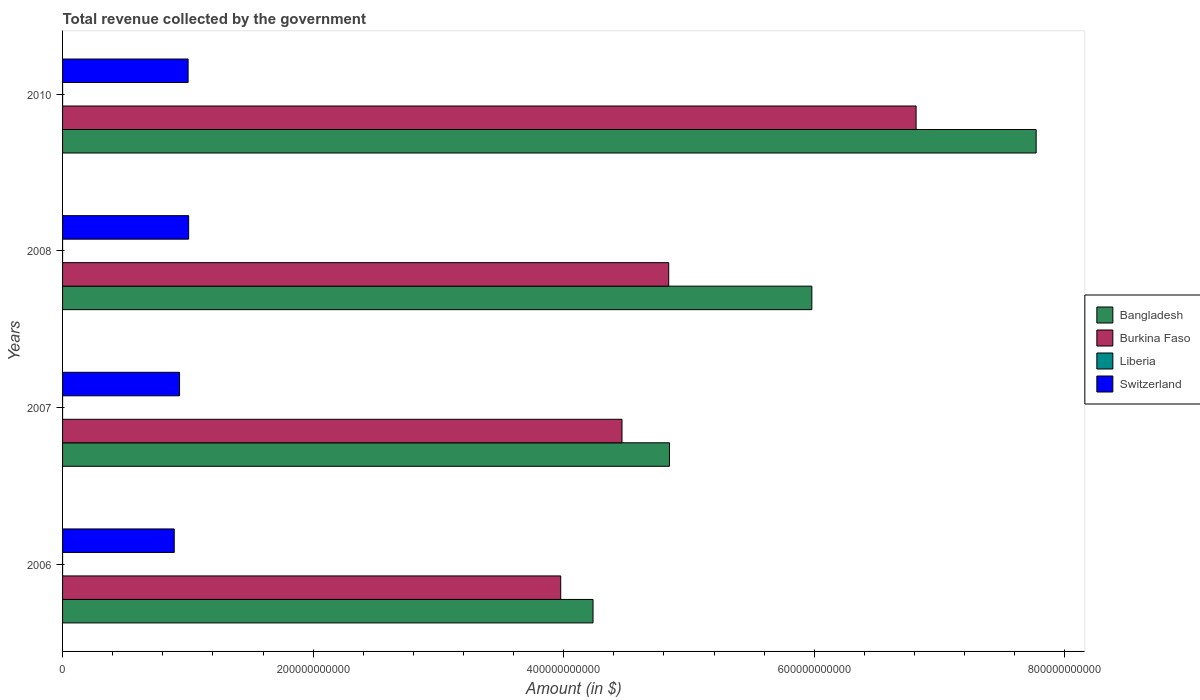How many different coloured bars are there?
Ensure brevity in your answer.  4. How many groups of bars are there?
Your response must be concise. 4. Are the number of bars per tick equal to the number of legend labels?
Make the answer very short. Yes. How many bars are there on the 1st tick from the top?
Provide a succinct answer. 4. How many bars are there on the 2nd tick from the bottom?
Give a very brief answer. 4. What is the label of the 2nd group of bars from the top?
Provide a succinct answer. 2008. In how many cases, is the number of bars for a given year not equal to the number of legend labels?
Keep it short and to the point. 0. What is the total revenue collected by the government in Burkina Faso in 2010?
Your response must be concise. 6.81e+11. Across all years, what is the maximum total revenue collected by the government in Burkina Faso?
Offer a very short reply. 6.81e+11. Across all years, what is the minimum total revenue collected by the government in Burkina Faso?
Offer a very short reply. 3.98e+11. In which year was the total revenue collected by the government in Switzerland maximum?
Your answer should be compact. 2008. In which year was the total revenue collected by the government in Bangladesh minimum?
Make the answer very short. 2006. What is the total total revenue collected by the government in Liberia in the graph?
Ensure brevity in your answer.  1.08e+07. What is the difference between the total revenue collected by the government in Bangladesh in 2006 and that in 2010?
Your answer should be compact. -3.54e+11. What is the difference between the total revenue collected by the government in Liberia in 2006 and the total revenue collected by the government in Bangladesh in 2007?
Make the answer very short. -4.84e+11. What is the average total revenue collected by the government in Bangladesh per year?
Offer a terse response. 5.71e+11. In the year 2008, what is the difference between the total revenue collected by the government in Burkina Faso and total revenue collected by the government in Bangladesh?
Make the answer very short. -1.14e+11. In how many years, is the total revenue collected by the government in Burkina Faso greater than 600000000000 $?
Offer a terse response. 1. What is the ratio of the total revenue collected by the government in Bangladesh in 2006 to that in 2008?
Make the answer very short. 0.71. Is the total revenue collected by the government in Switzerland in 2007 less than that in 2010?
Ensure brevity in your answer.  Yes. Is the difference between the total revenue collected by the government in Burkina Faso in 2007 and 2008 greater than the difference between the total revenue collected by the government in Bangladesh in 2007 and 2008?
Your response must be concise. Yes. What is the difference between the highest and the second highest total revenue collected by the government in Bangladesh?
Provide a short and direct response. 1.79e+11. What is the difference between the highest and the lowest total revenue collected by the government in Bangladesh?
Offer a very short reply. 3.54e+11. Is the sum of the total revenue collected by the government in Burkina Faso in 2008 and 2010 greater than the maximum total revenue collected by the government in Switzerland across all years?
Offer a very short reply. Yes. Is it the case that in every year, the sum of the total revenue collected by the government in Burkina Faso and total revenue collected by the government in Bangladesh is greater than the sum of total revenue collected by the government in Switzerland and total revenue collected by the government in Liberia?
Provide a succinct answer. No. What does the 1st bar from the top in 2007 represents?
Make the answer very short. Switzerland. What does the 2nd bar from the bottom in 2010 represents?
Provide a succinct answer. Burkina Faso. Are all the bars in the graph horizontal?
Offer a very short reply. Yes. How many years are there in the graph?
Keep it short and to the point. 4. What is the difference between two consecutive major ticks on the X-axis?
Your answer should be very brief. 2.00e+11. Does the graph contain grids?
Make the answer very short. No. Where does the legend appear in the graph?
Offer a very short reply. Center right. What is the title of the graph?
Your response must be concise. Total revenue collected by the government. What is the label or title of the X-axis?
Provide a short and direct response. Amount (in $). What is the label or title of the Y-axis?
Your answer should be very brief. Years. What is the Amount (in $) of Bangladesh in 2006?
Keep it short and to the point. 4.23e+11. What is the Amount (in $) of Burkina Faso in 2006?
Offer a very short reply. 3.98e+11. What is the Amount (in $) of Liberia in 2006?
Give a very brief answer. 1.46e+06. What is the Amount (in $) in Switzerland in 2006?
Provide a succinct answer. 8.91e+1. What is the Amount (in $) in Bangladesh in 2007?
Ensure brevity in your answer.  4.84e+11. What is the Amount (in $) of Burkina Faso in 2007?
Offer a very short reply. 4.47e+11. What is the Amount (in $) in Liberia in 2007?
Offer a very short reply. 2.40e+06. What is the Amount (in $) of Switzerland in 2007?
Offer a terse response. 9.34e+1. What is the Amount (in $) of Bangladesh in 2008?
Ensure brevity in your answer.  5.98e+11. What is the Amount (in $) of Burkina Faso in 2008?
Offer a very short reply. 4.84e+11. What is the Amount (in $) in Liberia in 2008?
Give a very brief answer. 3.18e+06. What is the Amount (in $) in Switzerland in 2008?
Give a very brief answer. 1.01e+11. What is the Amount (in $) in Bangladesh in 2010?
Your response must be concise. 7.77e+11. What is the Amount (in $) of Burkina Faso in 2010?
Provide a short and direct response. 6.81e+11. What is the Amount (in $) of Liberia in 2010?
Your answer should be compact. 3.78e+06. What is the Amount (in $) of Switzerland in 2010?
Make the answer very short. 1.00e+11. Across all years, what is the maximum Amount (in $) of Bangladesh?
Your answer should be very brief. 7.77e+11. Across all years, what is the maximum Amount (in $) in Burkina Faso?
Your answer should be compact. 6.81e+11. Across all years, what is the maximum Amount (in $) of Liberia?
Offer a very short reply. 3.78e+06. Across all years, what is the maximum Amount (in $) of Switzerland?
Your answer should be compact. 1.01e+11. Across all years, what is the minimum Amount (in $) of Bangladesh?
Provide a succinct answer. 4.23e+11. Across all years, what is the minimum Amount (in $) in Burkina Faso?
Give a very brief answer. 3.98e+11. Across all years, what is the minimum Amount (in $) of Liberia?
Offer a very short reply. 1.46e+06. Across all years, what is the minimum Amount (in $) of Switzerland?
Provide a short and direct response. 8.91e+1. What is the total Amount (in $) in Bangladesh in the graph?
Offer a very short reply. 2.28e+12. What is the total Amount (in $) of Burkina Faso in the graph?
Offer a terse response. 2.01e+12. What is the total Amount (in $) of Liberia in the graph?
Provide a short and direct response. 1.08e+07. What is the total Amount (in $) in Switzerland in the graph?
Ensure brevity in your answer.  3.83e+11. What is the difference between the Amount (in $) in Bangladesh in 2006 and that in 2007?
Your response must be concise. -6.10e+1. What is the difference between the Amount (in $) of Burkina Faso in 2006 and that in 2007?
Make the answer very short. -4.89e+1. What is the difference between the Amount (in $) in Liberia in 2006 and that in 2007?
Your answer should be very brief. -9.40e+05. What is the difference between the Amount (in $) in Switzerland in 2006 and that in 2007?
Ensure brevity in your answer.  -4.24e+09. What is the difference between the Amount (in $) of Bangladesh in 2006 and that in 2008?
Keep it short and to the point. -1.75e+11. What is the difference between the Amount (in $) of Burkina Faso in 2006 and that in 2008?
Your answer should be compact. -8.62e+1. What is the difference between the Amount (in $) in Liberia in 2006 and that in 2008?
Make the answer very short. -1.73e+06. What is the difference between the Amount (in $) in Switzerland in 2006 and that in 2008?
Your response must be concise. -1.15e+1. What is the difference between the Amount (in $) in Bangladesh in 2006 and that in 2010?
Your response must be concise. -3.54e+11. What is the difference between the Amount (in $) of Burkina Faso in 2006 and that in 2010?
Make the answer very short. -2.84e+11. What is the difference between the Amount (in $) in Liberia in 2006 and that in 2010?
Offer a very short reply. -2.33e+06. What is the difference between the Amount (in $) in Switzerland in 2006 and that in 2010?
Provide a short and direct response. -1.11e+1. What is the difference between the Amount (in $) of Bangladesh in 2007 and that in 2008?
Your answer should be very brief. -1.14e+11. What is the difference between the Amount (in $) of Burkina Faso in 2007 and that in 2008?
Give a very brief answer. -3.73e+1. What is the difference between the Amount (in $) of Liberia in 2007 and that in 2008?
Offer a very short reply. -7.87e+05. What is the difference between the Amount (in $) in Switzerland in 2007 and that in 2008?
Keep it short and to the point. -7.27e+09. What is the difference between the Amount (in $) of Bangladesh in 2007 and that in 2010?
Keep it short and to the point. -2.93e+11. What is the difference between the Amount (in $) in Burkina Faso in 2007 and that in 2010?
Make the answer very short. -2.35e+11. What is the difference between the Amount (in $) of Liberia in 2007 and that in 2010?
Make the answer very short. -1.39e+06. What is the difference between the Amount (in $) of Switzerland in 2007 and that in 2010?
Provide a short and direct response. -6.83e+09. What is the difference between the Amount (in $) in Bangladesh in 2008 and that in 2010?
Offer a terse response. -1.79e+11. What is the difference between the Amount (in $) of Burkina Faso in 2008 and that in 2010?
Give a very brief answer. -1.97e+11. What is the difference between the Amount (in $) of Liberia in 2008 and that in 2010?
Your answer should be very brief. -6.00e+05. What is the difference between the Amount (in $) of Switzerland in 2008 and that in 2010?
Ensure brevity in your answer.  4.42e+08. What is the difference between the Amount (in $) of Bangladesh in 2006 and the Amount (in $) of Burkina Faso in 2007?
Give a very brief answer. -2.31e+1. What is the difference between the Amount (in $) in Bangladesh in 2006 and the Amount (in $) in Liberia in 2007?
Keep it short and to the point. 4.23e+11. What is the difference between the Amount (in $) of Bangladesh in 2006 and the Amount (in $) of Switzerland in 2007?
Provide a succinct answer. 3.30e+11. What is the difference between the Amount (in $) of Burkina Faso in 2006 and the Amount (in $) of Liberia in 2007?
Offer a very short reply. 3.98e+11. What is the difference between the Amount (in $) of Burkina Faso in 2006 and the Amount (in $) of Switzerland in 2007?
Your answer should be very brief. 3.04e+11. What is the difference between the Amount (in $) of Liberia in 2006 and the Amount (in $) of Switzerland in 2007?
Your answer should be compact. -9.34e+1. What is the difference between the Amount (in $) of Bangladesh in 2006 and the Amount (in $) of Burkina Faso in 2008?
Your response must be concise. -6.04e+1. What is the difference between the Amount (in $) of Bangladesh in 2006 and the Amount (in $) of Liberia in 2008?
Your answer should be very brief. 4.23e+11. What is the difference between the Amount (in $) of Bangladesh in 2006 and the Amount (in $) of Switzerland in 2008?
Keep it short and to the point. 3.23e+11. What is the difference between the Amount (in $) in Burkina Faso in 2006 and the Amount (in $) in Liberia in 2008?
Keep it short and to the point. 3.98e+11. What is the difference between the Amount (in $) of Burkina Faso in 2006 and the Amount (in $) of Switzerland in 2008?
Your answer should be very brief. 2.97e+11. What is the difference between the Amount (in $) in Liberia in 2006 and the Amount (in $) in Switzerland in 2008?
Make the answer very short. -1.01e+11. What is the difference between the Amount (in $) of Bangladesh in 2006 and the Amount (in $) of Burkina Faso in 2010?
Your answer should be very brief. -2.58e+11. What is the difference between the Amount (in $) in Bangladesh in 2006 and the Amount (in $) in Liberia in 2010?
Offer a terse response. 4.23e+11. What is the difference between the Amount (in $) in Bangladesh in 2006 and the Amount (in $) in Switzerland in 2010?
Your answer should be compact. 3.23e+11. What is the difference between the Amount (in $) in Burkina Faso in 2006 and the Amount (in $) in Liberia in 2010?
Your response must be concise. 3.98e+11. What is the difference between the Amount (in $) in Burkina Faso in 2006 and the Amount (in $) in Switzerland in 2010?
Provide a succinct answer. 2.97e+11. What is the difference between the Amount (in $) in Liberia in 2006 and the Amount (in $) in Switzerland in 2010?
Keep it short and to the point. -1.00e+11. What is the difference between the Amount (in $) of Bangladesh in 2007 and the Amount (in $) of Burkina Faso in 2008?
Offer a terse response. 5.88e+08. What is the difference between the Amount (in $) of Bangladesh in 2007 and the Amount (in $) of Liberia in 2008?
Your response must be concise. 4.84e+11. What is the difference between the Amount (in $) in Bangladesh in 2007 and the Amount (in $) in Switzerland in 2008?
Your answer should be very brief. 3.84e+11. What is the difference between the Amount (in $) in Burkina Faso in 2007 and the Amount (in $) in Liberia in 2008?
Ensure brevity in your answer.  4.47e+11. What is the difference between the Amount (in $) of Burkina Faso in 2007 and the Amount (in $) of Switzerland in 2008?
Offer a very short reply. 3.46e+11. What is the difference between the Amount (in $) in Liberia in 2007 and the Amount (in $) in Switzerland in 2008?
Make the answer very short. -1.01e+11. What is the difference between the Amount (in $) in Bangladesh in 2007 and the Amount (in $) in Burkina Faso in 2010?
Provide a succinct answer. -1.97e+11. What is the difference between the Amount (in $) in Bangladesh in 2007 and the Amount (in $) in Liberia in 2010?
Ensure brevity in your answer.  4.84e+11. What is the difference between the Amount (in $) in Bangladesh in 2007 and the Amount (in $) in Switzerland in 2010?
Offer a very short reply. 3.84e+11. What is the difference between the Amount (in $) of Burkina Faso in 2007 and the Amount (in $) of Liberia in 2010?
Make the answer very short. 4.47e+11. What is the difference between the Amount (in $) of Burkina Faso in 2007 and the Amount (in $) of Switzerland in 2010?
Provide a short and direct response. 3.46e+11. What is the difference between the Amount (in $) in Liberia in 2007 and the Amount (in $) in Switzerland in 2010?
Provide a succinct answer. -1.00e+11. What is the difference between the Amount (in $) of Bangladesh in 2008 and the Amount (in $) of Burkina Faso in 2010?
Make the answer very short. -8.32e+1. What is the difference between the Amount (in $) in Bangladesh in 2008 and the Amount (in $) in Liberia in 2010?
Ensure brevity in your answer.  5.98e+11. What is the difference between the Amount (in $) in Bangladesh in 2008 and the Amount (in $) in Switzerland in 2010?
Ensure brevity in your answer.  4.98e+11. What is the difference between the Amount (in $) in Burkina Faso in 2008 and the Amount (in $) in Liberia in 2010?
Your answer should be very brief. 4.84e+11. What is the difference between the Amount (in $) in Burkina Faso in 2008 and the Amount (in $) in Switzerland in 2010?
Offer a very short reply. 3.84e+11. What is the difference between the Amount (in $) of Liberia in 2008 and the Amount (in $) of Switzerland in 2010?
Keep it short and to the point. -1.00e+11. What is the average Amount (in $) in Bangladesh per year?
Offer a terse response. 5.71e+11. What is the average Amount (in $) of Burkina Faso per year?
Give a very brief answer. 5.02e+11. What is the average Amount (in $) of Liberia per year?
Provide a succinct answer. 2.70e+06. What is the average Amount (in $) in Switzerland per year?
Provide a succinct answer. 9.58e+1. In the year 2006, what is the difference between the Amount (in $) of Bangladesh and Amount (in $) of Burkina Faso?
Your answer should be very brief. 2.58e+1. In the year 2006, what is the difference between the Amount (in $) in Bangladesh and Amount (in $) in Liberia?
Keep it short and to the point. 4.23e+11. In the year 2006, what is the difference between the Amount (in $) of Bangladesh and Amount (in $) of Switzerland?
Your answer should be very brief. 3.34e+11. In the year 2006, what is the difference between the Amount (in $) of Burkina Faso and Amount (in $) of Liberia?
Offer a very short reply. 3.98e+11. In the year 2006, what is the difference between the Amount (in $) of Burkina Faso and Amount (in $) of Switzerland?
Your answer should be compact. 3.08e+11. In the year 2006, what is the difference between the Amount (in $) in Liberia and Amount (in $) in Switzerland?
Make the answer very short. -8.91e+1. In the year 2007, what is the difference between the Amount (in $) of Bangladesh and Amount (in $) of Burkina Faso?
Offer a very short reply. 3.79e+1. In the year 2007, what is the difference between the Amount (in $) of Bangladesh and Amount (in $) of Liberia?
Offer a terse response. 4.84e+11. In the year 2007, what is the difference between the Amount (in $) in Bangladesh and Amount (in $) in Switzerland?
Offer a terse response. 3.91e+11. In the year 2007, what is the difference between the Amount (in $) of Burkina Faso and Amount (in $) of Liberia?
Your answer should be very brief. 4.47e+11. In the year 2007, what is the difference between the Amount (in $) in Burkina Faso and Amount (in $) in Switzerland?
Provide a succinct answer. 3.53e+11. In the year 2007, what is the difference between the Amount (in $) in Liberia and Amount (in $) in Switzerland?
Offer a terse response. -9.34e+1. In the year 2008, what is the difference between the Amount (in $) in Bangladesh and Amount (in $) in Burkina Faso?
Provide a short and direct response. 1.14e+11. In the year 2008, what is the difference between the Amount (in $) of Bangladesh and Amount (in $) of Liberia?
Provide a succinct answer. 5.98e+11. In the year 2008, what is the difference between the Amount (in $) of Bangladesh and Amount (in $) of Switzerland?
Offer a terse response. 4.97e+11. In the year 2008, what is the difference between the Amount (in $) in Burkina Faso and Amount (in $) in Liberia?
Offer a terse response. 4.84e+11. In the year 2008, what is the difference between the Amount (in $) in Burkina Faso and Amount (in $) in Switzerland?
Your response must be concise. 3.83e+11. In the year 2008, what is the difference between the Amount (in $) of Liberia and Amount (in $) of Switzerland?
Your response must be concise. -1.01e+11. In the year 2010, what is the difference between the Amount (in $) in Bangladesh and Amount (in $) in Burkina Faso?
Offer a very short reply. 9.58e+1. In the year 2010, what is the difference between the Amount (in $) in Bangladesh and Amount (in $) in Liberia?
Your response must be concise. 7.77e+11. In the year 2010, what is the difference between the Amount (in $) of Bangladesh and Amount (in $) of Switzerland?
Give a very brief answer. 6.77e+11. In the year 2010, what is the difference between the Amount (in $) in Burkina Faso and Amount (in $) in Liberia?
Make the answer very short. 6.81e+11. In the year 2010, what is the difference between the Amount (in $) of Burkina Faso and Amount (in $) of Switzerland?
Ensure brevity in your answer.  5.81e+11. In the year 2010, what is the difference between the Amount (in $) in Liberia and Amount (in $) in Switzerland?
Make the answer very short. -1.00e+11. What is the ratio of the Amount (in $) of Bangladesh in 2006 to that in 2007?
Provide a succinct answer. 0.87. What is the ratio of the Amount (in $) of Burkina Faso in 2006 to that in 2007?
Your answer should be compact. 0.89. What is the ratio of the Amount (in $) of Liberia in 2006 to that in 2007?
Offer a very short reply. 0.61. What is the ratio of the Amount (in $) in Switzerland in 2006 to that in 2007?
Make the answer very short. 0.95. What is the ratio of the Amount (in $) in Bangladesh in 2006 to that in 2008?
Provide a succinct answer. 0.71. What is the ratio of the Amount (in $) of Burkina Faso in 2006 to that in 2008?
Make the answer very short. 0.82. What is the ratio of the Amount (in $) in Liberia in 2006 to that in 2008?
Your answer should be very brief. 0.46. What is the ratio of the Amount (in $) of Switzerland in 2006 to that in 2008?
Ensure brevity in your answer.  0.89. What is the ratio of the Amount (in $) in Bangladesh in 2006 to that in 2010?
Provide a succinct answer. 0.54. What is the ratio of the Amount (in $) in Burkina Faso in 2006 to that in 2010?
Your response must be concise. 0.58. What is the ratio of the Amount (in $) in Liberia in 2006 to that in 2010?
Make the answer very short. 0.38. What is the ratio of the Amount (in $) of Switzerland in 2006 to that in 2010?
Provide a short and direct response. 0.89. What is the ratio of the Amount (in $) in Bangladesh in 2007 to that in 2008?
Keep it short and to the point. 0.81. What is the ratio of the Amount (in $) of Burkina Faso in 2007 to that in 2008?
Your answer should be very brief. 0.92. What is the ratio of the Amount (in $) in Liberia in 2007 to that in 2008?
Make the answer very short. 0.75. What is the ratio of the Amount (in $) of Switzerland in 2007 to that in 2008?
Make the answer very short. 0.93. What is the ratio of the Amount (in $) of Bangladesh in 2007 to that in 2010?
Your answer should be compact. 0.62. What is the ratio of the Amount (in $) of Burkina Faso in 2007 to that in 2010?
Ensure brevity in your answer.  0.66. What is the ratio of the Amount (in $) in Liberia in 2007 to that in 2010?
Your answer should be compact. 0.63. What is the ratio of the Amount (in $) of Switzerland in 2007 to that in 2010?
Offer a very short reply. 0.93. What is the ratio of the Amount (in $) in Bangladesh in 2008 to that in 2010?
Provide a succinct answer. 0.77. What is the ratio of the Amount (in $) of Burkina Faso in 2008 to that in 2010?
Your response must be concise. 0.71. What is the ratio of the Amount (in $) in Liberia in 2008 to that in 2010?
Your answer should be compact. 0.84. What is the difference between the highest and the second highest Amount (in $) of Bangladesh?
Give a very brief answer. 1.79e+11. What is the difference between the highest and the second highest Amount (in $) in Burkina Faso?
Your answer should be very brief. 1.97e+11. What is the difference between the highest and the second highest Amount (in $) in Liberia?
Give a very brief answer. 6.00e+05. What is the difference between the highest and the second highest Amount (in $) of Switzerland?
Offer a terse response. 4.42e+08. What is the difference between the highest and the lowest Amount (in $) in Bangladesh?
Offer a terse response. 3.54e+11. What is the difference between the highest and the lowest Amount (in $) in Burkina Faso?
Offer a very short reply. 2.84e+11. What is the difference between the highest and the lowest Amount (in $) of Liberia?
Provide a short and direct response. 2.33e+06. What is the difference between the highest and the lowest Amount (in $) of Switzerland?
Give a very brief answer. 1.15e+1. 